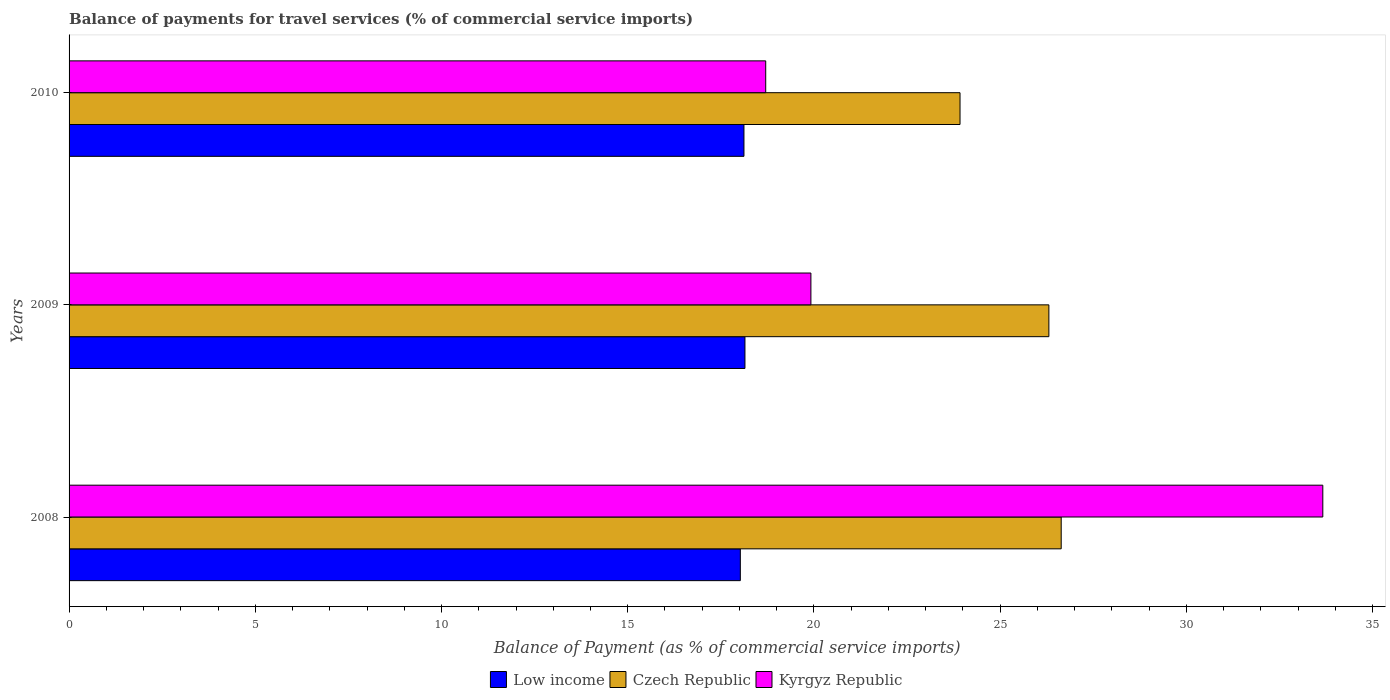How many different coloured bars are there?
Give a very brief answer. 3. Are the number of bars per tick equal to the number of legend labels?
Give a very brief answer. Yes. How many bars are there on the 3rd tick from the top?
Offer a very short reply. 3. In how many cases, is the number of bars for a given year not equal to the number of legend labels?
Ensure brevity in your answer.  0. What is the balance of payments for travel services in Low income in 2008?
Give a very brief answer. 18.02. Across all years, what is the maximum balance of payments for travel services in Czech Republic?
Provide a short and direct response. 26.64. Across all years, what is the minimum balance of payments for travel services in Kyrgyz Republic?
Give a very brief answer. 18.7. In which year was the balance of payments for travel services in Low income minimum?
Your answer should be compact. 2008. What is the total balance of payments for travel services in Czech Republic in the graph?
Ensure brevity in your answer.  76.87. What is the difference between the balance of payments for travel services in Kyrgyz Republic in 2008 and that in 2009?
Give a very brief answer. 13.74. What is the difference between the balance of payments for travel services in Czech Republic in 2009 and the balance of payments for travel services in Kyrgyz Republic in 2008?
Provide a succinct answer. -7.36. What is the average balance of payments for travel services in Kyrgyz Republic per year?
Offer a very short reply. 24.09. In the year 2010, what is the difference between the balance of payments for travel services in Kyrgyz Republic and balance of payments for travel services in Low income?
Give a very brief answer. 0.58. In how many years, is the balance of payments for travel services in Low income greater than 33 %?
Your answer should be compact. 0. What is the ratio of the balance of payments for travel services in Kyrgyz Republic in 2009 to that in 2010?
Provide a succinct answer. 1.06. Is the difference between the balance of payments for travel services in Kyrgyz Republic in 2008 and 2009 greater than the difference between the balance of payments for travel services in Low income in 2008 and 2009?
Provide a succinct answer. Yes. What is the difference between the highest and the second highest balance of payments for travel services in Czech Republic?
Provide a short and direct response. 0.33. What is the difference between the highest and the lowest balance of payments for travel services in Kyrgyz Republic?
Your answer should be compact. 14.96. What does the 3rd bar from the top in 2008 represents?
Your response must be concise. Low income. What does the 1st bar from the bottom in 2010 represents?
Make the answer very short. Low income. How many bars are there?
Provide a succinct answer. 9. Are the values on the major ticks of X-axis written in scientific E-notation?
Provide a succinct answer. No. Does the graph contain any zero values?
Offer a terse response. No. Does the graph contain grids?
Offer a terse response. No. Where does the legend appear in the graph?
Provide a succinct answer. Bottom center. How are the legend labels stacked?
Provide a short and direct response. Horizontal. What is the title of the graph?
Your response must be concise. Balance of payments for travel services (% of commercial service imports). What is the label or title of the X-axis?
Your answer should be very brief. Balance of Payment (as % of commercial service imports). What is the label or title of the Y-axis?
Your response must be concise. Years. What is the Balance of Payment (as % of commercial service imports) in Low income in 2008?
Make the answer very short. 18.02. What is the Balance of Payment (as % of commercial service imports) of Czech Republic in 2008?
Offer a terse response. 26.64. What is the Balance of Payment (as % of commercial service imports) in Kyrgyz Republic in 2008?
Give a very brief answer. 33.66. What is the Balance of Payment (as % of commercial service imports) in Low income in 2009?
Your answer should be very brief. 18.15. What is the Balance of Payment (as % of commercial service imports) of Czech Republic in 2009?
Your answer should be compact. 26.31. What is the Balance of Payment (as % of commercial service imports) of Kyrgyz Republic in 2009?
Ensure brevity in your answer.  19.92. What is the Balance of Payment (as % of commercial service imports) in Low income in 2010?
Offer a terse response. 18.12. What is the Balance of Payment (as % of commercial service imports) of Czech Republic in 2010?
Offer a terse response. 23.92. What is the Balance of Payment (as % of commercial service imports) of Kyrgyz Republic in 2010?
Ensure brevity in your answer.  18.7. Across all years, what is the maximum Balance of Payment (as % of commercial service imports) of Low income?
Give a very brief answer. 18.15. Across all years, what is the maximum Balance of Payment (as % of commercial service imports) of Czech Republic?
Your answer should be compact. 26.64. Across all years, what is the maximum Balance of Payment (as % of commercial service imports) in Kyrgyz Republic?
Your response must be concise. 33.66. Across all years, what is the minimum Balance of Payment (as % of commercial service imports) in Low income?
Your answer should be compact. 18.02. Across all years, what is the minimum Balance of Payment (as % of commercial service imports) in Czech Republic?
Provide a succinct answer. 23.92. Across all years, what is the minimum Balance of Payment (as % of commercial service imports) of Kyrgyz Republic?
Offer a terse response. 18.7. What is the total Balance of Payment (as % of commercial service imports) in Low income in the graph?
Offer a terse response. 54.29. What is the total Balance of Payment (as % of commercial service imports) of Czech Republic in the graph?
Provide a short and direct response. 76.87. What is the total Balance of Payment (as % of commercial service imports) in Kyrgyz Republic in the graph?
Keep it short and to the point. 72.28. What is the difference between the Balance of Payment (as % of commercial service imports) in Low income in 2008 and that in 2009?
Your answer should be very brief. -0.12. What is the difference between the Balance of Payment (as % of commercial service imports) of Czech Republic in 2008 and that in 2009?
Ensure brevity in your answer.  0.33. What is the difference between the Balance of Payment (as % of commercial service imports) in Kyrgyz Republic in 2008 and that in 2009?
Your answer should be very brief. 13.74. What is the difference between the Balance of Payment (as % of commercial service imports) in Low income in 2008 and that in 2010?
Offer a terse response. -0.1. What is the difference between the Balance of Payment (as % of commercial service imports) in Czech Republic in 2008 and that in 2010?
Provide a succinct answer. 2.72. What is the difference between the Balance of Payment (as % of commercial service imports) in Kyrgyz Republic in 2008 and that in 2010?
Your answer should be compact. 14.96. What is the difference between the Balance of Payment (as % of commercial service imports) of Low income in 2009 and that in 2010?
Offer a very short reply. 0.03. What is the difference between the Balance of Payment (as % of commercial service imports) of Czech Republic in 2009 and that in 2010?
Provide a short and direct response. 2.39. What is the difference between the Balance of Payment (as % of commercial service imports) of Kyrgyz Republic in 2009 and that in 2010?
Make the answer very short. 1.21. What is the difference between the Balance of Payment (as % of commercial service imports) in Low income in 2008 and the Balance of Payment (as % of commercial service imports) in Czech Republic in 2009?
Provide a succinct answer. -8.28. What is the difference between the Balance of Payment (as % of commercial service imports) in Low income in 2008 and the Balance of Payment (as % of commercial service imports) in Kyrgyz Republic in 2009?
Provide a short and direct response. -1.9. What is the difference between the Balance of Payment (as % of commercial service imports) in Czech Republic in 2008 and the Balance of Payment (as % of commercial service imports) in Kyrgyz Republic in 2009?
Your answer should be very brief. 6.72. What is the difference between the Balance of Payment (as % of commercial service imports) in Low income in 2008 and the Balance of Payment (as % of commercial service imports) in Czech Republic in 2010?
Give a very brief answer. -5.9. What is the difference between the Balance of Payment (as % of commercial service imports) in Low income in 2008 and the Balance of Payment (as % of commercial service imports) in Kyrgyz Republic in 2010?
Keep it short and to the point. -0.68. What is the difference between the Balance of Payment (as % of commercial service imports) in Czech Republic in 2008 and the Balance of Payment (as % of commercial service imports) in Kyrgyz Republic in 2010?
Keep it short and to the point. 7.93. What is the difference between the Balance of Payment (as % of commercial service imports) of Low income in 2009 and the Balance of Payment (as % of commercial service imports) of Czech Republic in 2010?
Your response must be concise. -5.77. What is the difference between the Balance of Payment (as % of commercial service imports) in Low income in 2009 and the Balance of Payment (as % of commercial service imports) in Kyrgyz Republic in 2010?
Provide a short and direct response. -0.56. What is the difference between the Balance of Payment (as % of commercial service imports) of Czech Republic in 2009 and the Balance of Payment (as % of commercial service imports) of Kyrgyz Republic in 2010?
Provide a succinct answer. 7.6. What is the average Balance of Payment (as % of commercial service imports) of Low income per year?
Your answer should be compact. 18.1. What is the average Balance of Payment (as % of commercial service imports) of Czech Republic per year?
Offer a very short reply. 25.62. What is the average Balance of Payment (as % of commercial service imports) of Kyrgyz Republic per year?
Keep it short and to the point. 24.09. In the year 2008, what is the difference between the Balance of Payment (as % of commercial service imports) in Low income and Balance of Payment (as % of commercial service imports) in Czech Republic?
Make the answer very short. -8.62. In the year 2008, what is the difference between the Balance of Payment (as % of commercial service imports) in Low income and Balance of Payment (as % of commercial service imports) in Kyrgyz Republic?
Offer a very short reply. -15.64. In the year 2008, what is the difference between the Balance of Payment (as % of commercial service imports) in Czech Republic and Balance of Payment (as % of commercial service imports) in Kyrgyz Republic?
Offer a very short reply. -7.02. In the year 2009, what is the difference between the Balance of Payment (as % of commercial service imports) of Low income and Balance of Payment (as % of commercial service imports) of Czech Republic?
Make the answer very short. -8.16. In the year 2009, what is the difference between the Balance of Payment (as % of commercial service imports) in Low income and Balance of Payment (as % of commercial service imports) in Kyrgyz Republic?
Your response must be concise. -1.77. In the year 2009, what is the difference between the Balance of Payment (as % of commercial service imports) in Czech Republic and Balance of Payment (as % of commercial service imports) in Kyrgyz Republic?
Ensure brevity in your answer.  6.39. In the year 2010, what is the difference between the Balance of Payment (as % of commercial service imports) in Low income and Balance of Payment (as % of commercial service imports) in Czech Republic?
Provide a short and direct response. -5.8. In the year 2010, what is the difference between the Balance of Payment (as % of commercial service imports) in Low income and Balance of Payment (as % of commercial service imports) in Kyrgyz Republic?
Your answer should be compact. -0.58. In the year 2010, what is the difference between the Balance of Payment (as % of commercial service imports) in Czech Republic and Balance of Payment (as % of commercial service imports) in Kyrgyz Republic?
Keep it short and to the point. 5.22. What is the ratio of the Balance of Payment (as % of commercial service imports) of Czech Republic in 2008 to that in 2009?
Ensure brevity in your answer.  1.01. What is the ratio of the Balance of Payment (as % of commercial service imports) in Kyrgyz Republic in 2008 to that in 2009?
Provide a succinct answer. 1.69. What is the ratio of the Balance of Payment (as % of commercial service imports) of Low income in 2008 to that in 2010?
Offer a terse response. 0.99. What is the ratio of the Balance of Payment (as % of commercial service imports) of Czech Republic in 2008 to that in 2010?
Offer a very short reply. 1.11. What is the ratio of the Balance of Payment (as % of commercial service imports) of Kyrgyz Republic in 2008 to that in 2010?
Keep it short and to the point. 1.8. What is the ratio of the Balance of Payment (as % of commercial service imports) of Low income in 2009 to that in 2010?
Your answer should be compact. 1. What is the ratio of the Balance of Payment (as % of commercial service imports) in Czech Republic in 2009 to that in 2010?
Give a very brief answer. 1.1. What is the ratio of the Balance of Payment (as % of commercial service imports) of Kyrgyz Republic in 2009 to that in 2010?
Make the answer very short. 1.06. What is the difference between the highest and the second highest Balance of Payment (as % of commercial service imports) in Low income?
Provide a short and direct response. 0.03. What is the difference between the highest and the second highest Balance of Payment (as % of commercial service imports) of Czech Republic?
Ensure brevity in your answer.  0.33. What is the difference between the highest and the second highest Balance of Payment (as % of commercial service imports) in Kyrgyz Republic?
Provide a short and direct response. 13.74. What is the difference between the highest and the lowest Balance of Payment (as % of commercial service imports) of Low income?
Provide a short and direct response. 0.12. What is the difference between the highest and the lowest Balance of Payment (as % of commercial service imports) of Czech Republic?
Offer a very short reply. 2.72. What is the difference between the highest and the lowest Balance of Payment (as % of commercial service imports) of Kyrgyz Republic?
Your answer should be compact. 14.96. 